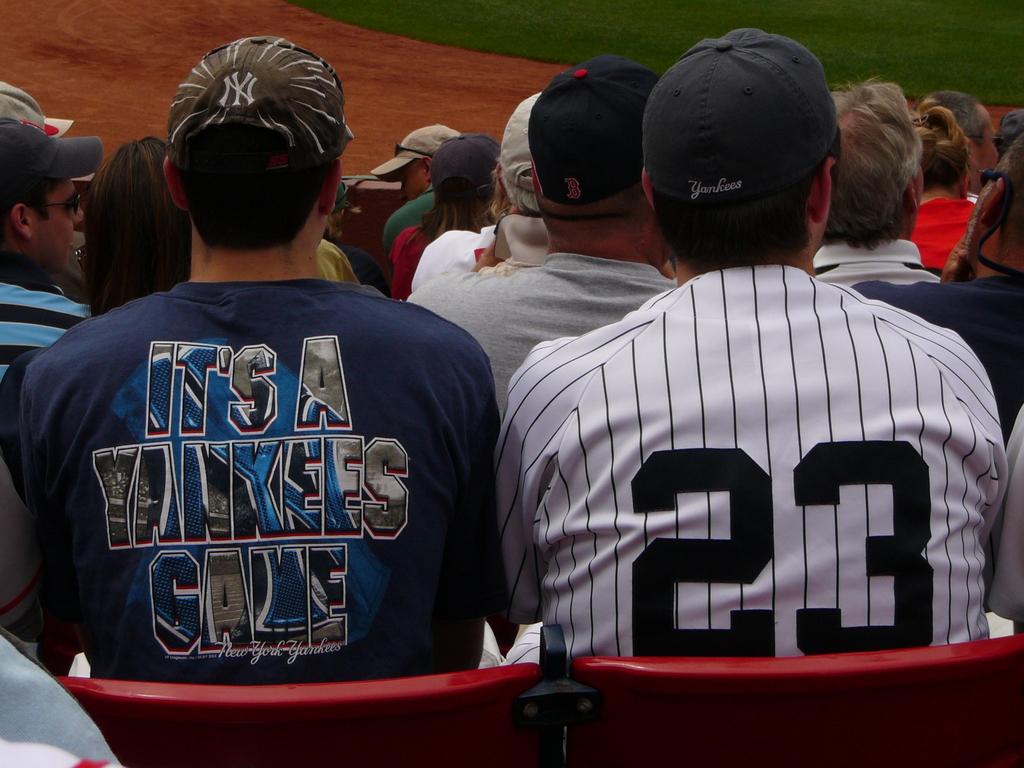What is the number on the shirt in white?
Your answer should be very brief. 23. 